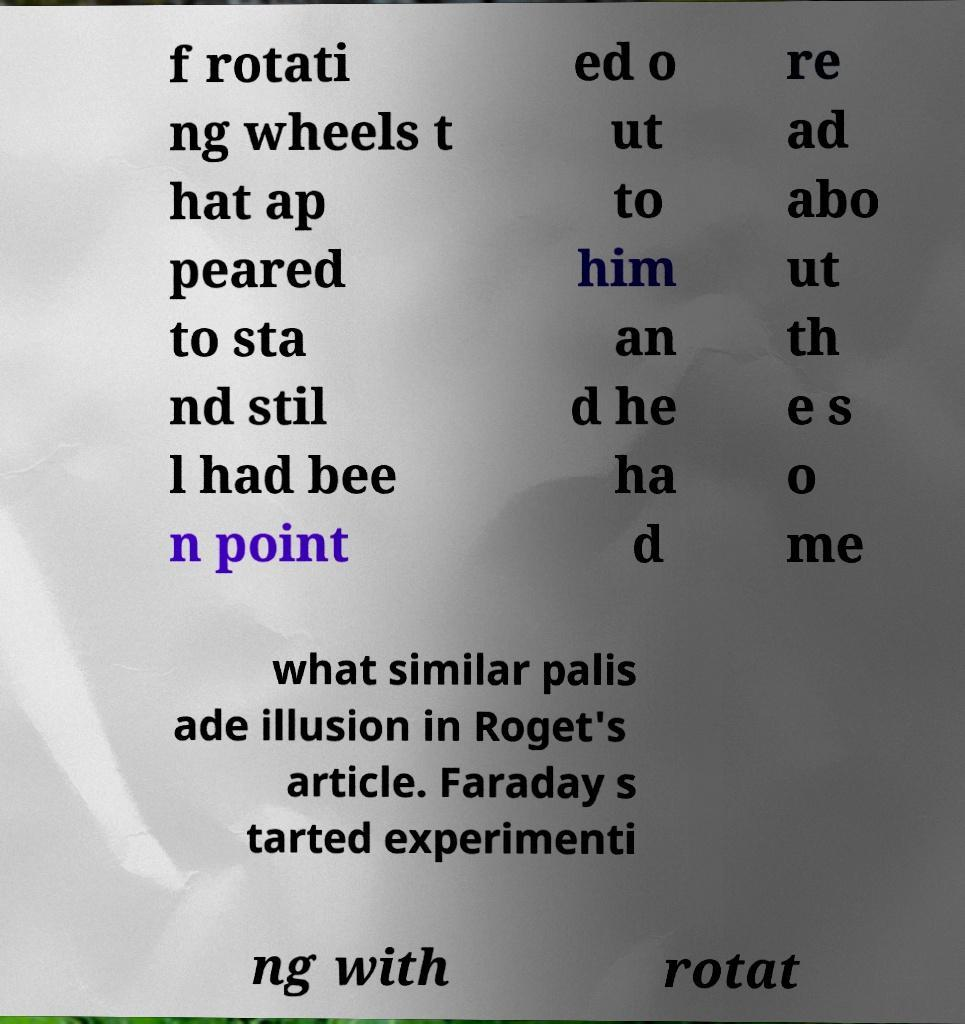Please read and relay the text visible in this image. What does it say? f rotati ng wheels t hat ap peared to sta nd stil l had bee n point ed o ut to him an d he ha d re ad abo ut th e s o me what similar palis ade illusion in Roget's article. Faraday s tarted experimenti ng with rotat 